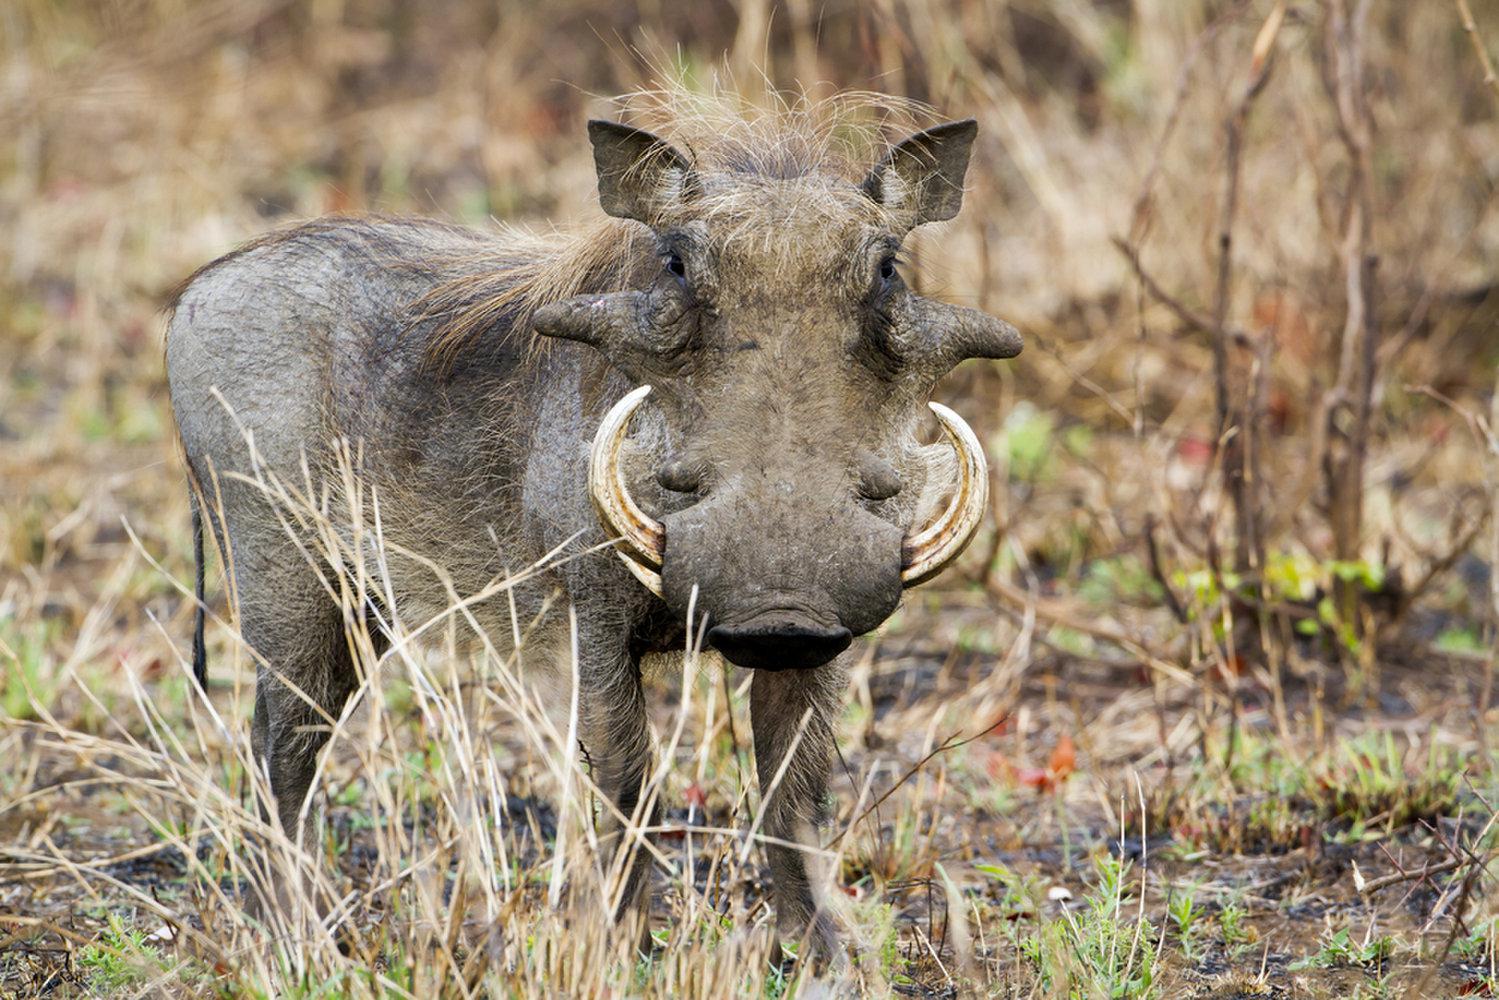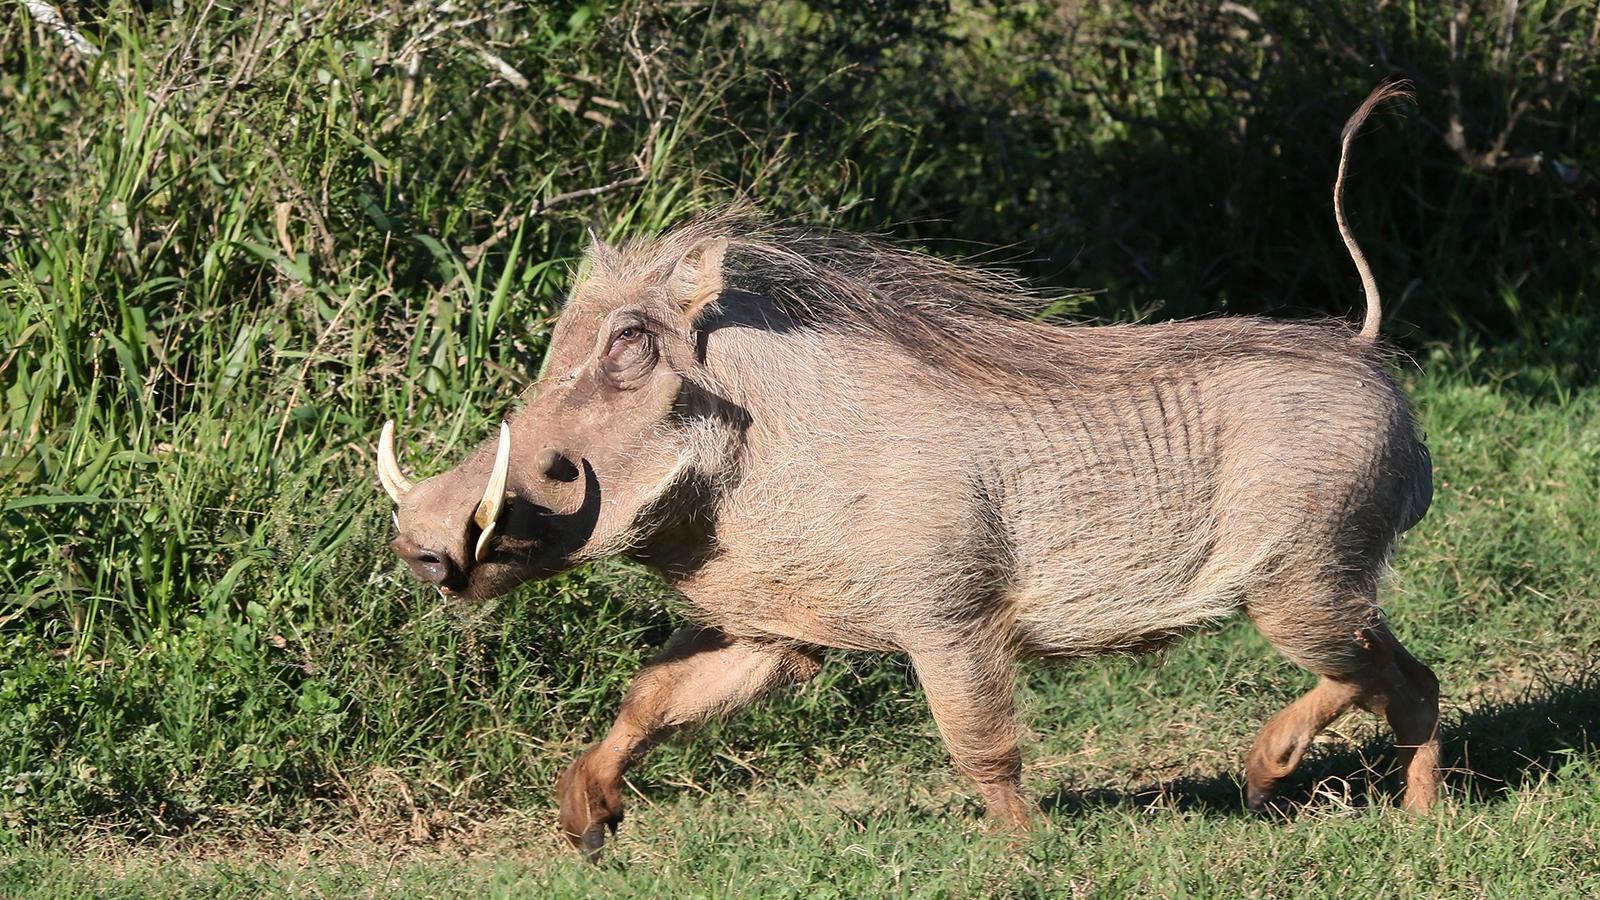The first image is the image on the left, the second image is the image on the right. Assess this claim about the two images: "There is a dirt and tan colored boar in the grass who’s head is facing left.". Correct or not? Answer yes or no. Yes. 